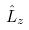<formula> <loc_0><loc_0><loc_500><loc_500>\hat { L } _ { z }</formula> 